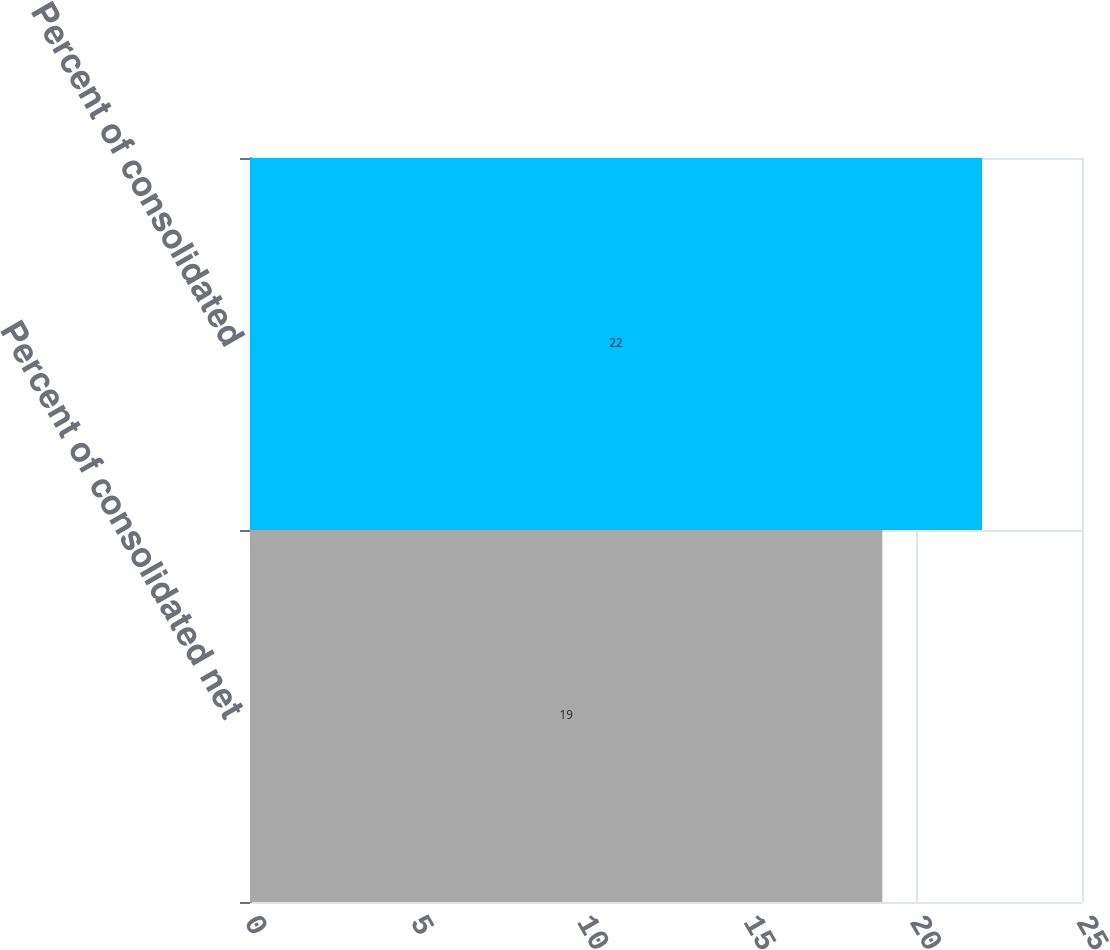Convert chart to OTSL. <chart><loc_0><loc_0><loc_500><loc_500><bar_chart><fcel>Percent of consolidated net<fcel>Percent of consolidated<nl><fcel>19<fcel>22<nl></chart> 